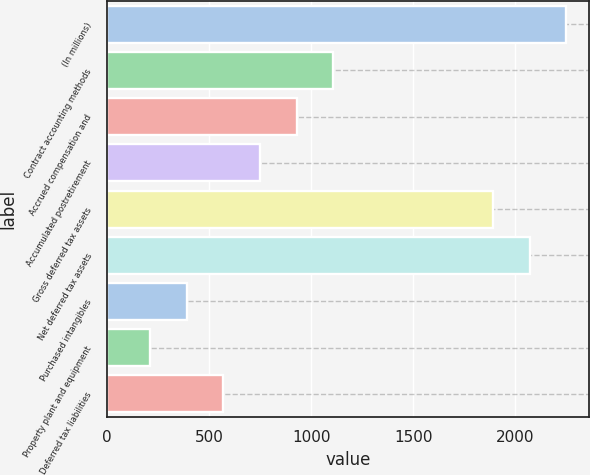<chart> <loc_0><loc_0><loc_500><loc_500><bar_chart><fcel>(In millions)<fcel>Contract accounting methods<fcel>Accrued compensation and<fcel>Accumulated postretirement<fcel>Gross deferred tax assets<fcel>Net deferred tax assets<fcel>Purchased intangibles<fcel>Property plant and equipment<fcel>Deferred tax liabilities<nl><fcel>2249.8<fcel>1108<fcel>928.6<fcel>749.2<fcel>1891<fcel>2070.4<fcel>390.4<fcel>211<fcel>569.8<nl></chart> 